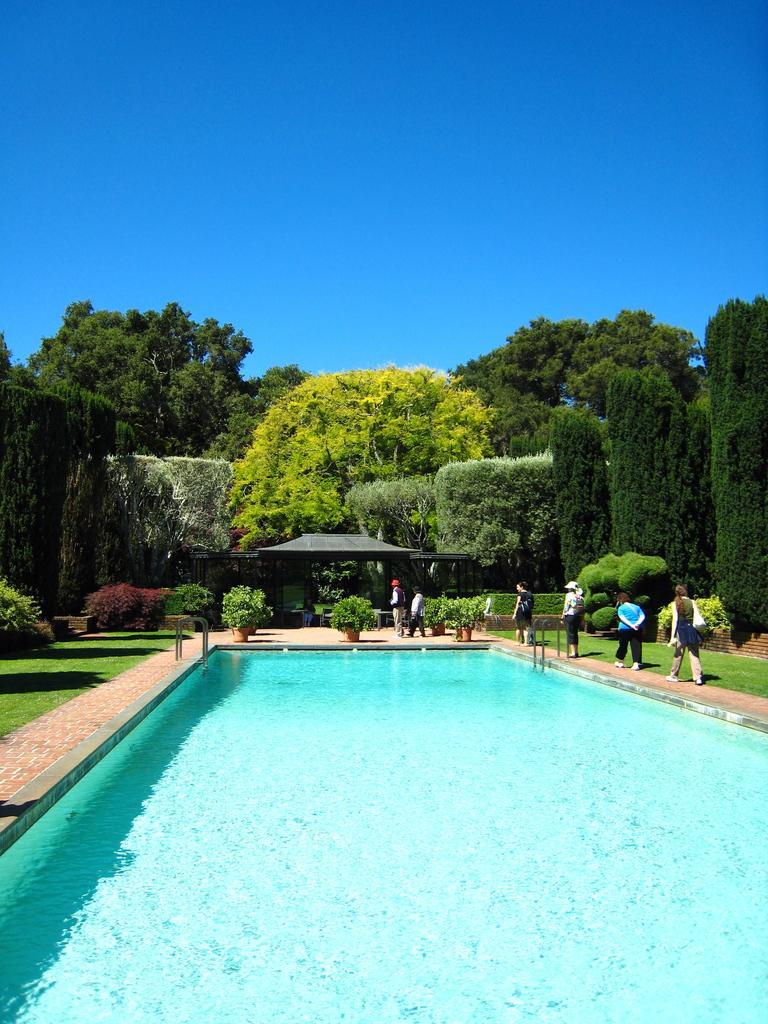How would you summarize this image in a sentence or two? In the foreground of the picture there are plants, people, grass and a swimming pool. In the center of the picture there are trees and a construction. Sky is sunny. 